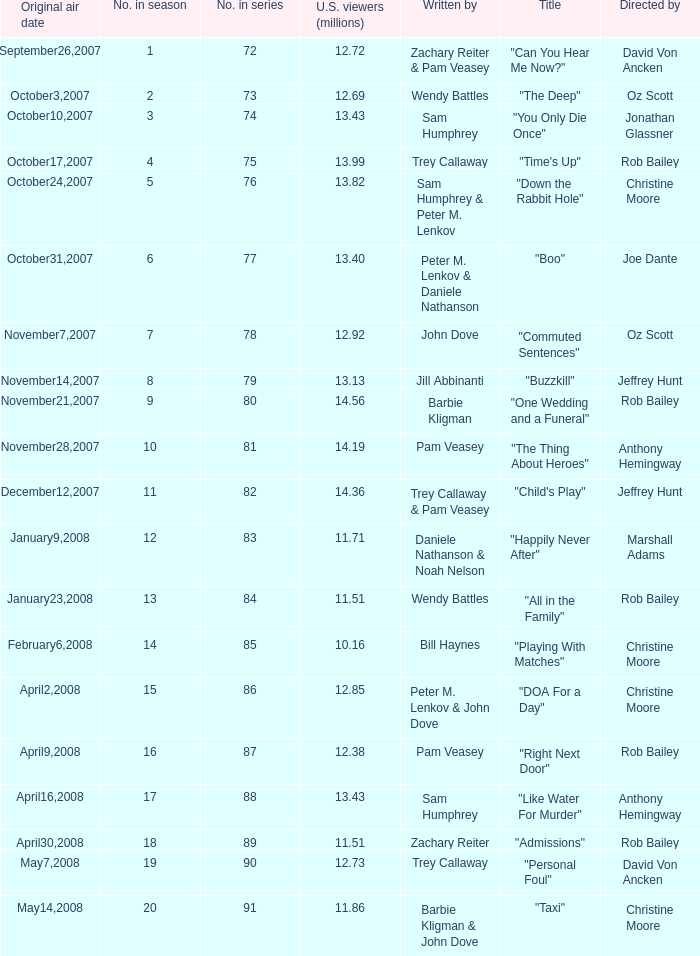How many millions of U.S. viewers watched the episode directed by Rob Bailey and written by Pam Veasey? 12.38. 